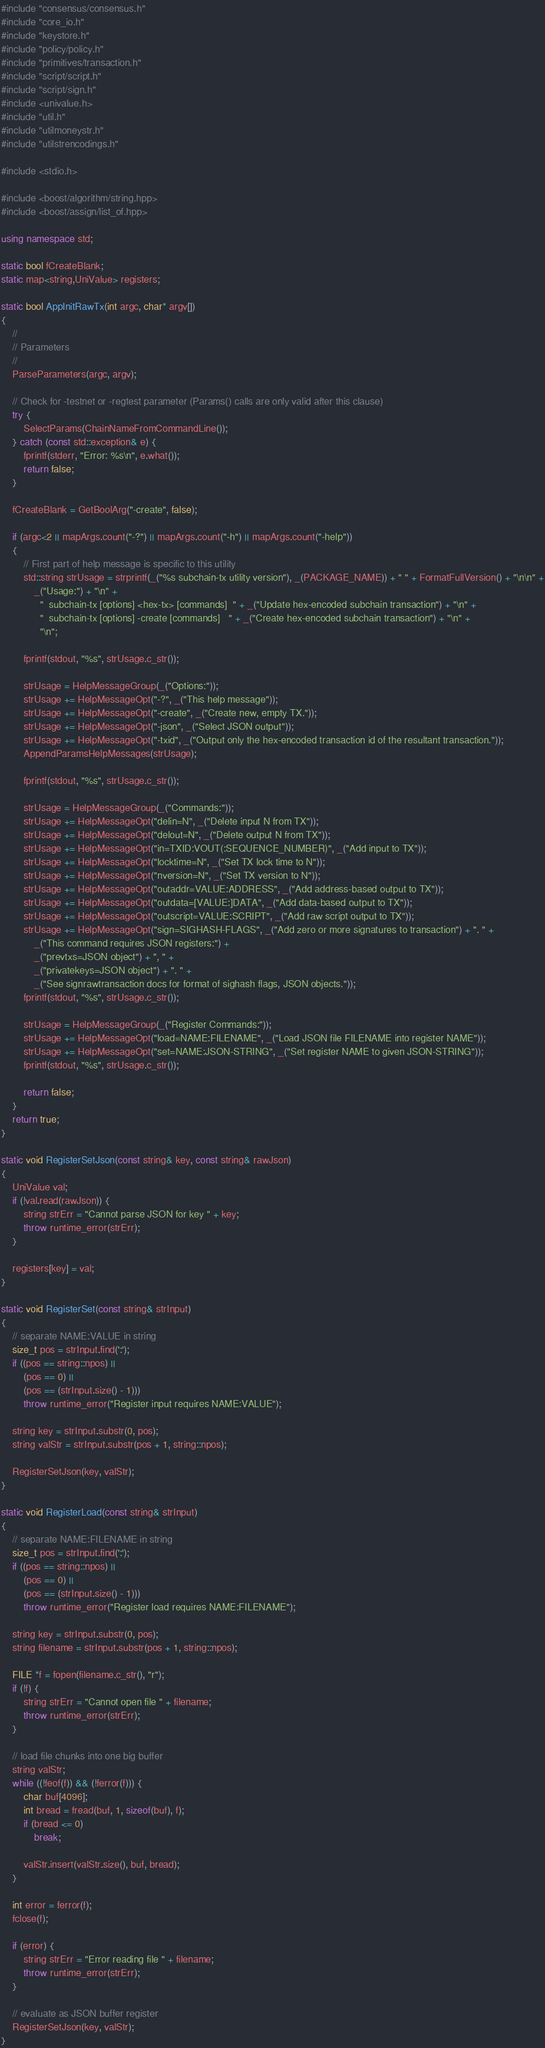<code> <loc_0><loc_0><loc_500><loc_500><_C++_>#include "consensus/consensus.h"
#include "core_io.h"
#include "keystore.h"
#include "policy/policy.h"
#include "primitives/transaction.h"
#include "script/script.h"
#include "script/sign.h"
#include <univalue.h>
#include "util.h"
#include "utilmoneystr.h"
#include "utilstrencodings.h"

#include <stdio.h>

#include <boost/algorithm/string.hpp>
#include <boost/assign/list_of.hpp>

using namespace std;

static bool fCreateBlank;
static map<string,UniValue> registers;

static bool AppInitRawTx(int argc, char* argv[])
{
    //
    // Parameters
    //
    ParseParameters(argc, argv);

    // Check for -testnet or -regtest parameter (Params() calls are only valid after this clause)
    try {
        SelectParams(ChainNameFromCommandLine());
    } catch (const std::exception& e) {
        fprintf(stderr, "Error: %s\n", e.what());
        return false;
    }

    fCreateBlank = GetBoolArg("-create", false);

    if (argc<2 || mapArgs.count("-?") || mapArgs.count("-h") || mapArgs.count("-help"))
    {
        // First part of help message is specific to this utility
        std::string strUsage = strprintf(_("%s subchain-tx utility version"), _(PACKAGE_NAME)) + " " + FormatFullVersion() + "\n\n" +
            _("Usage:") + "\n" +
              "  subchain-tx [options] <hex-tx> [commands]  " + _("Update hex-encoded subchain transaction") + "\n" +
              "  subchain-tx [options] -create [commands]   " + _("Create hex-encoded subchain transaction") + "\n" +
              "\n";

        fprintf(stdout, "%s", strUsage.c_str());

        strUsage = HelpMessageGroup(_("Options:"));
        strUsage += HelpMessageOpt("-?", _("This help message"));
        strUsage += HelpMessageOpt("-create", _("Create new, empty TX."));
        strUsage += HelpMessageOpt("-json", _("Select JSON output"));
        strUsage += HelpMessageOpt("-txid", _("Output only the hex-encoded transaction id of the resultant transaction."));
        AppendParamsHelpMessages(strUsage);

        fprintf(stdout, "%s", strUsage.c_str());

        strUsage = HelpMessageGroup(_("Commands:"));
        strUsage += HelpMessageOpt("delin=N", _("Delete input N from TX"));
        strUsage += HelpMessageOpt("delout=N", _("Delete output N from TX"));
        strUsage += HelpMessageOpt("in=TXID:VOUT(:SEQUENCE_NUMBER)", _("Add input to TX"));
        strUsage += HelpMessageOpt("locktime=N", _("Set TX lock time to N"));
        strUsage += HelpMessageOpt("nversion=N", _("Set TX version to N"));
        strUsage += HelpMessageOpt("outaddr=VALUE:ADDRESS", _("Add address-based output to TX"));
        strUsage += HelpMessageOpt("outdata=[VALUE:]DATA", _("Add data-based output to TX"));
        strUsage += HelpMessageOpt("outscript=VALUE:SCRIPT", _("Add raw script output to TX"));
        strUsage += HelpMessageOpt("sign=SIGHASH-FLAGS", _("Add zero or more signatures to transaction") + ". " +
            _("This command requires JSON registers:") +
            _("prevtxs=JSON object") + ", " +
            _("privatekeys=JSON object") + ". " +
            _("See signrawtransaction docs for format of sighash flags, JSON objects."));
        fprintf(stdout, "%s", strUsage.c_str());

        strUsage = HelpMessageGroup(_("Register Commands:"));
        strUsage += HelpMessageOpt("load=NAME:FILENAME", _("Load JSON file FILENAME into register NAME"));
        strUsage += HelpMessageOpt("set=NAME:JSON-STRING", _("Set register NAME to given JSON-STRING"));
        fprintf(stdout, "%s", strUsage.c_str());

        return false;
    }
    return true;
}

static void RegisterSetJson(const string& key, const string& rawJson)
{
    UniValue val;
    if (!val.read(rawJson)) {
        string strErr = "Cannot parse JSON for key " + key;
        throw runtime_error(strErr);
    }

    registers[key] = val;
}

static void RegisterSet(const string& strInput)
{
    // separate NAME:VALUE in string
    size_t pos = strInput.find(':');
    if ((pos == string::npos) ||
        (pos == 0) ||
        (pos == (strInput.size() - 1)))
        throw runtime_error("Register input requires NAME:VALUE");

    string key = strInput.substr(0, pos);
    string valStr = strInput.substr(pos + 1, string::npos);

    RegisterSetJson(key, valStr);
}

static void RegisterLoad(const string& strInput)
{
    // separate NAME:FILENAME in string
    size_t pos = strInput.find(':');
    if ((pos == string::npos) ||
        (pos == 0) ||
        (pos == (strInput.size() - 1)))
        throw runtime_error("Register load requires NAME:FILENAME");

    string key = strInput.substr(0, pos);
    string filename = strInput.substr(pos + 1, string::npos);

    FILE *f = fopen(filename.c_str(), "r");
    if (!f) {
        string strErr = "Cannot open file " + filename;
        throw runtime_error(strErr);
    }

    // load file chunks into one big buffer
    string valStr;
    while ((!feof(f)) && (!ferror(f))) {
        char buf[4096];
        int bread = fread(buf, 1, sizeof(buf), f);
        if (bread <= 0)
            break;

        valStr.insert(valStr.size(), buf, bread);
    }

    int error = ferror(f);
    fclose(f);

    if (error) {
        string strErr = "Error reading file " + filename;
        throw runtime_error(strErr);
    }

    // evaluate as JSON buffer register
    RegisterSetJson(key, valStr);
}
</code> 